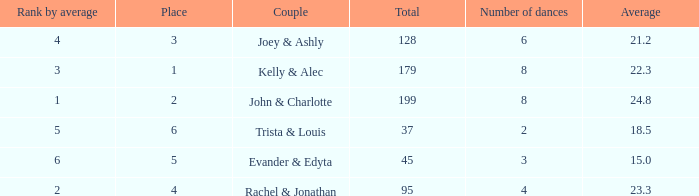What is the highest average that has 6 dances and a total of over 128? None. 